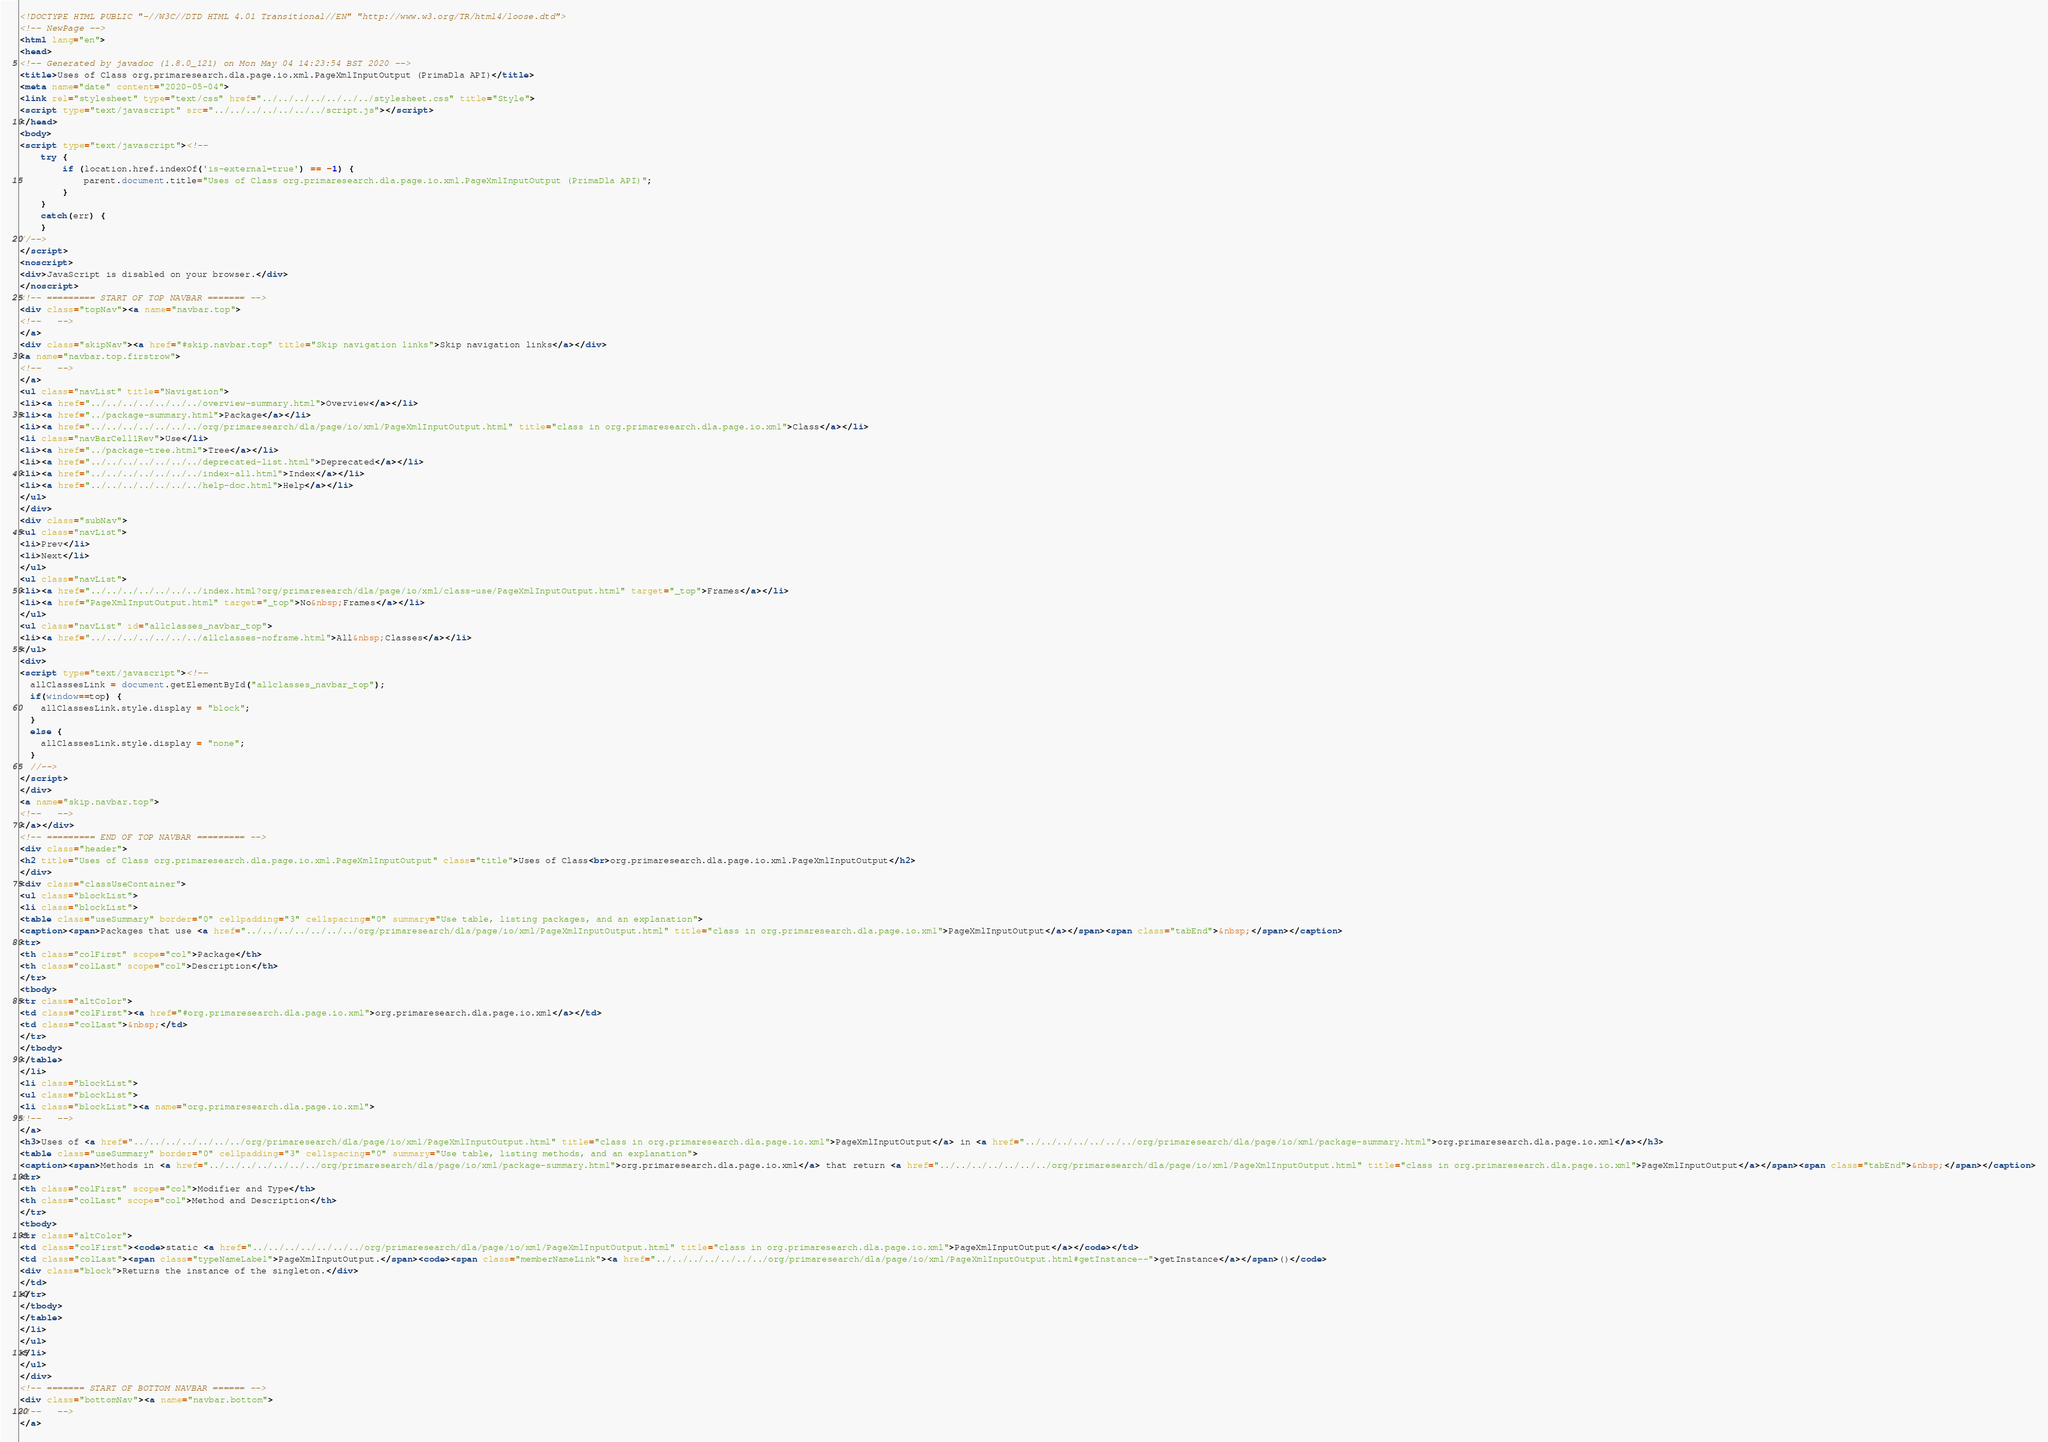<code> <loc_0><loc_0><loc_500><loc_500><_HTML_><!DOCTYPE HTML PUBLIC "-//W3C//DTD HTML 4.01 Transitional//EN" "http://www.w3.org/TR/html4/loose.dtd">
<!-- NewPage -->
<html lang="en">
<head>
<!-- Generated by javadoc (1.8.0_121) on Mon May 04 14:23:54 BST 2020 -->
<title>Uses of Class org.primaresearch.dla.page.io.xml.PageXmlInputOutput (PrimaDla API)</title>
<meta name="date" content="2020-05-04">
<link rel="stylesheet" type="text/css" href="../../../../../../../stylesheet.css" title="Style">
<script type="text/javascript" src="../../../../../../../script.js"></script>
</head>
<body>
<script type="text/javascript"><!--
    try {
        if (location.href.indexOf('is-external=true') == -1) {
            parent.document.title="Uses of Class org.primaresearch.dla.page.io.xml.PageXmlInputOutput (PrimaDla API)";
        }
    }
    catch(err) {
    }
//-->
</script>
<noscript>
<div>JavaScript is disabled on your browser.</div>
</noscript>
<!-- ========= START OF TOP NAVBAR ======= -->
<div class="topNav"><a name="navbar.top">
<!--   -->
</a>
<div class="skipNav"><a href="#skip.navbar.top" title="Skip navigation links">Skip navigation links</a></div>
<a name="navbar.top.firstrow">
<!--   -->
</a>
<ul class="navList" title="Navigation">
<li><a href="../../../../../../../overview-summary.html">Overview</a></li>
<li><a href="../package-summary.html">Package</a></li>
<li><a href="../../../../../../../org/primaresearch/dla/page/io/xml/PageXmlInputOutput.html" title="class in org.primaresearch.dla.page.io.xml">Class</a></li>
<li class="navBarCell1Rev">Use</li>
<li><a href="../package-tree.html">Tree</a></li>
<li><a href="../../../../../../../deprecated-list.html">Deprecated</a></li>
<li><a href="../../../../../../../index-all.html">Index</a></li>
<li><a href="../../../../../../../help-doc.html">Help</a></li>
</ul>
</div>
<div class="subNav">
<ul class="navList">
<li>Prev</li>
<li>Next</li>
</ul>
<ul class="navList">
<li><a href="../../../../../../../index.html?org/primaresearch/dla/page/io/xml/class-use/PageXmlInputOutput.html" target="_top">Frames</a></li>
<li><a href="PageXmlInputOutput.html" target="_top">No&nbsp;Frames</a></li>
</ul>
<ul class="navList" id="allclasses_navbar_top">
<li><a href="../../../../../../../allclasses-noframe.html">All&nbsp;Classes</a></li>
</ul>
<div>
<script type="text/javascript"><!--
  allClassesLink = document.getElementById("allclasses_navbar_top");
  if(window==top) {
    allClassesLink.style.display = "block";
  }
  else {
    allClassesLink.style.display = "none";
  }
  //-->
</script>
</div>
<a name="skip.navbar.top">
<!--   -->
</a></div>
<!-- ========= END OF TOP NAVBAR ========= -->
<div class="header">
<h2 title="Uses of Class org.primaresearch.dla.page.io.xml.PageXmlInputOutput" class="title">Uses of Class<br>org.primaresearch.dla.page.io.xml.PageXmlInputOutput</h2>
</div>
<div class="classUseContainer">
<ul class="blockList">
<li class="blockList">
<table class="useSummary" border="0" cellpadding="3" cellspacing="0" summary="Use table, listing packages, and an explanation">
<caption><span>Packages that use <a href="../../../../../../../org/primaresearch/dla/page/io/xml/PageXmlInputOutput.html" title="class in org.primaresearch.dla.page.io.xml">PageXmlInputOutput</a></span><span class="tabEnd">&nbsp;</span></caption>
<tr>
<th class="colFirst" scope="col">Package</th>
<th class="colLast" scope="col">Description</th>
</tr>
<tbody>
<tr class="altColor">
<td class="colFirst"><a href="#org.primaresearch.dla.page.io.xml">org.primaresearch.dla.page.io.xml</a></td>
<td class="colLast">&nbsp;</td>
</tr>
</tbody>
</table>
</li>
<li class="blockList">
<ul class="blockList">
<li class="blockList"><a name="org.primaresearch.dla.page.io.xml">
<!--   -->
</a>
<h3>Uses of <a href="../../../../../../../org/primaresearch/dla/page/io/xml/PageXmlInputOutput.html" title="class in org.primaresearch.dla.page.io.xml">PageXmlInputOutput</a> in <a href="../../../../../../../org/primaresearch/dla/page/io/xml/package-summary.html">org.primaresearch.dla.page.io.xml</a></h3>
<table class="useSummary" border="0" cellpadding="3" cellspacing="0" summary="Use table, listing methods, and an explanation">
<caption><span>Methods in <a href="../../../../../../../org/primaresearch/dla/page/io/xml/package-summary.html">org.primaresearch.dla.page.io.xml</a> that return <a href="../../../../../../../org/primaresearch/dla/page/io/xml/PageXmlInputOutput.html" title="class in org.primaresearch.dla.page.io.xml">PageXmlInputOutput</a></span><span class="tabEnd">&nbsp;</span></caption>
<tr>
<th class="colFirst" scope="col">Modifier and Type</th>
<th class="colLast" scope="col">Method and Description</th>
</tr>
<tbody>
<tr class="altColor">
<td class="colFirst"><code>static <a href="../../../../../../../org/primaresearch/dla/page/io/xml/PageXmlInputOutput.html" title="class in org.primaresearch.dla.page.io.xml">PageXmlInputOutput</a></code></td>
<td class="colLast"><span class="typeNameLabel">PageXmlInputOutput.</span><code><span class="memberNameLink"><a href="../../../../../../../org/primaresearch/dla/page/io/xml/PageXmlInputOutput.html#getInstance--">getInstance</a></span>()</code>
<div class="block">Returns the instance of the singleton.</div>
</td>
</tr>
</tbody>
</table>
</li>
</ul>
</li>
</ul>
</div>
<!-- ======= START OF BOTTOM NAVBAR ====== -->
<div class="bottomNav"><a name="navbar.bottom">
<!--   -->
</a></code> 